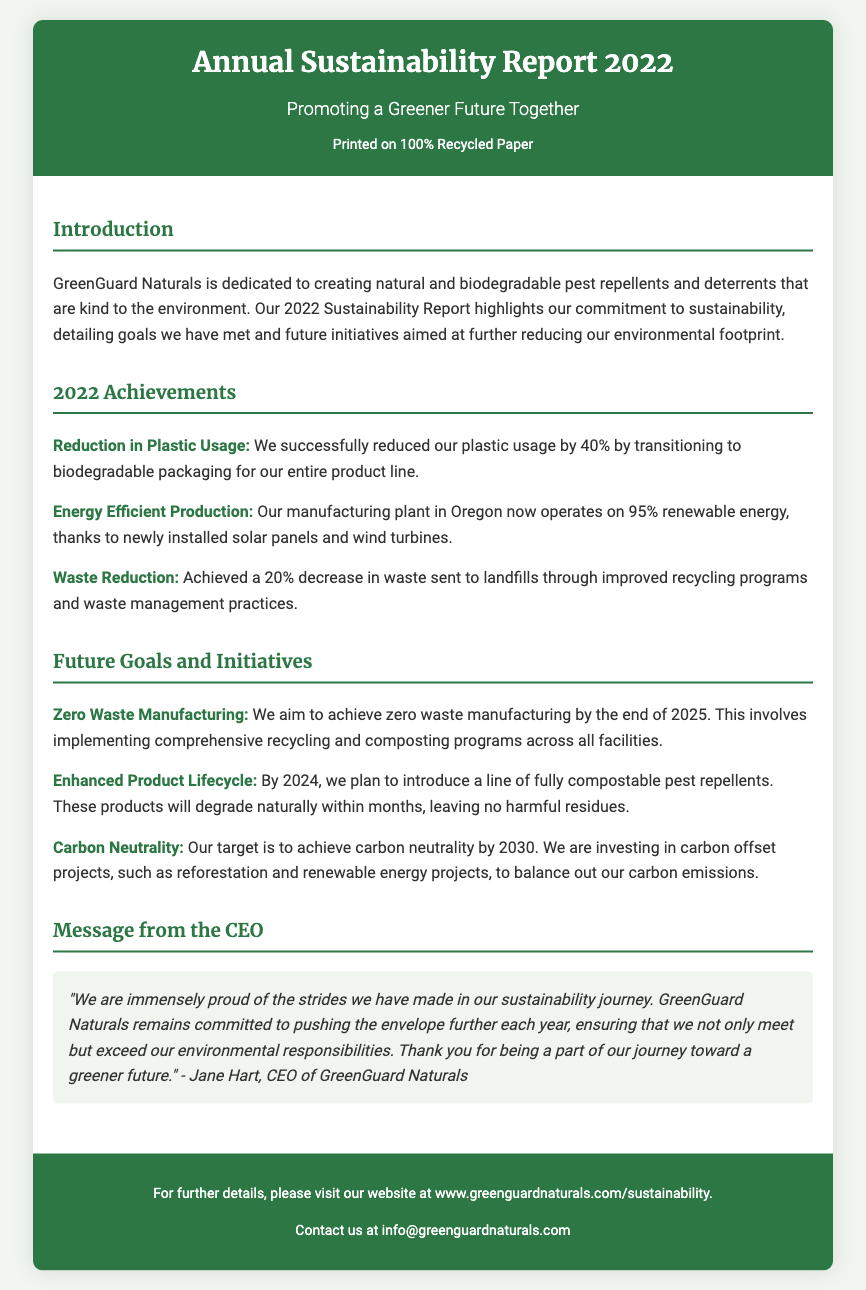What is the title of the report? The title of the report is indicated at the top of the document.
Answer: Annual Sustainability Report 2022 What percentage of plastic usage was reduced? The document states the percentage reduction achieved in plastic usage.
Answer: 40% What year is the target for carbon neutrality? The document lists the year by which the company aims to achieve carbon neutrality.
Answer: 2030 Who is the CEO of GreenGuard Naturals? The document mentions the CEO in the message section.
Answer: Jane Hart What is the goal for zero waste manufacturing? The document specifies the ambition for zero waste manufacturing along with the target date.
Answer: By the end of 2025 What is mentioned as a future initiative regarding product lifecycle? The document outlines a future goal related to product lifecycle.
Answer: Fully compostable pest repellents What kind of paper was the report printed on? The document indicates the type of paper used for printing.
Answer: 100% Recycled Paper What energy percentage does the manufacturing plant operate on? The document highlights the energy efficiency achieved in the manufacturing plant.
Answer: 95% renewable energy 